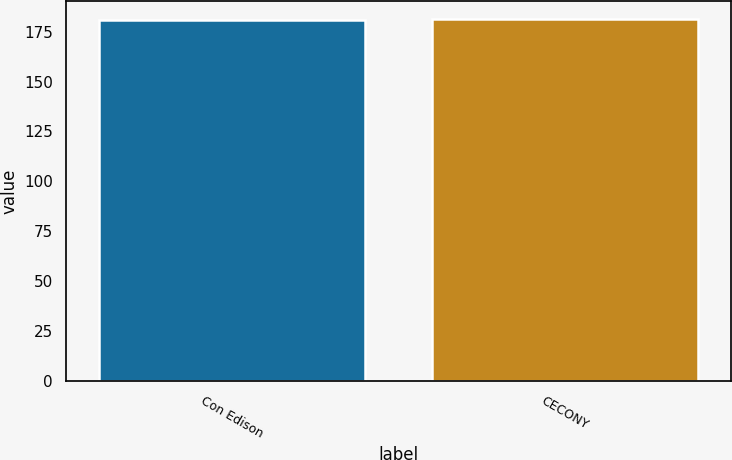Convert chart. <chart><loc_0><loc_0><loc_500><loc_500><bar_chart><fcel>Con Edison<fcel>CECONY<nl><fcel>181<fcel>181.1<nl></chart> 